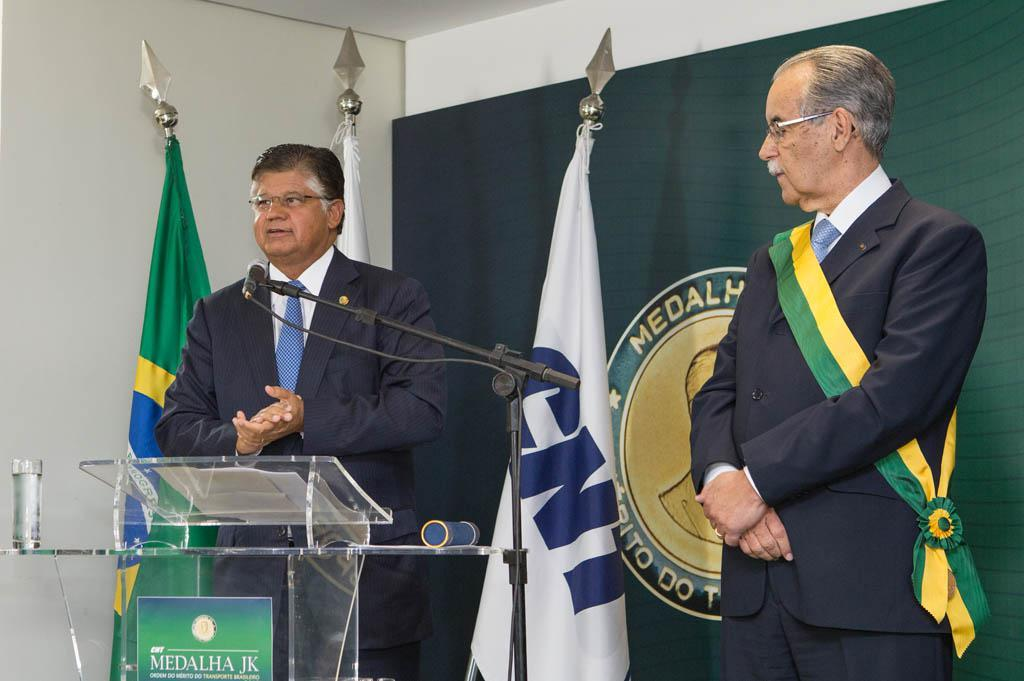What is the man in the image doing? The man is standing in front of a podium in the image. What object is the man standing in front of? The man is standing in front of a podium. What object is near the man standing beside the podium? There is a microphone in the image. Who else is present in the image? There is another man standing beside the microphone. What can be seen in the background of the image? There are three flags and a poster in the background of the image. What type of picture is the man holding in the image? There is no picture present in the image; the man is standing in front of a podium with a microphone and another man beside him. 